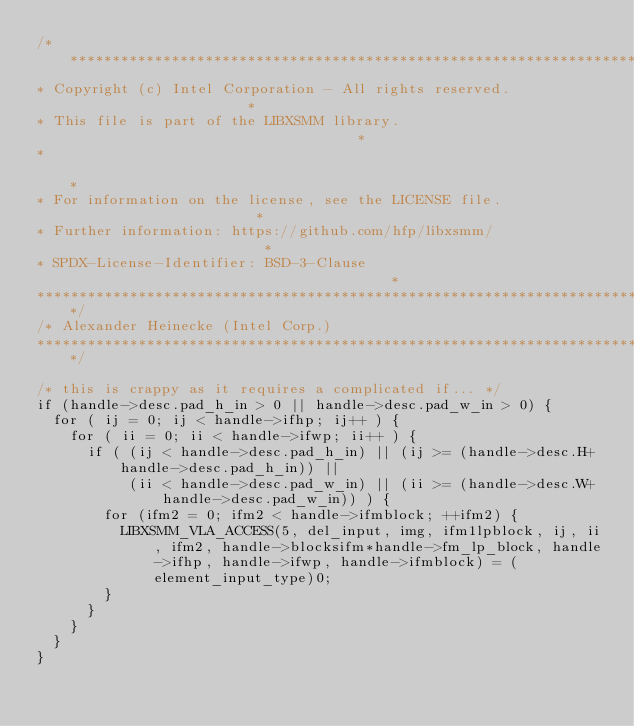Convert code to text. <code><loc_0><loc_0><loc_500><loc_500><_C_>/******************************************************************************
* Copyright (c) Intel Corporation - All rights reserved.                      *
* This file is part of the LIBXSMM library.                                   *
*                                                                             *
* For information on the license, see the LICENSE file.                       *
* Further information: https://github.com/hfp/libxsmm/                        *
* SPDX-License-Identifier: BSD-3-Clause                                       *
******************************************************************************/
/* Alexander Heinecke (Intel Corp.)
******************************************************************************/

/* this is crappy as it requires a complicated if... */
if (handle->desc.pad_h_in > 0 || handle->desc.pad_w_in > 0) {
  for ( ij = 0; ij < handle->ifhp; ij++ ) {
    for ( ii = 0; ii < handle->ifwp; ii++ ) {
      if ( (ij < handle->desc.pad_h_in) || (ij >= (handle->desc.H+handle->desc.pad_h_in)) ||
           (ii < handle->desc.pad_w_in) || (ii >= (handle->desc.W+handle->desc.pad_w_in)) ) {
        for (ifm2 = 0; ifm2 < handle->ifmblock; ++ifm2) {
          LIBXSMM_VLA_ACCESS(5, del_input, img, ifm1lpblock, ij, ii, ifm2, handle->blocksifm*handle->fm_lp_block, handle->ifhp, handle->ifwp, handle->ifmblock) = (element_input_type)0;
        }
      }
    }
  }
}

</code> 